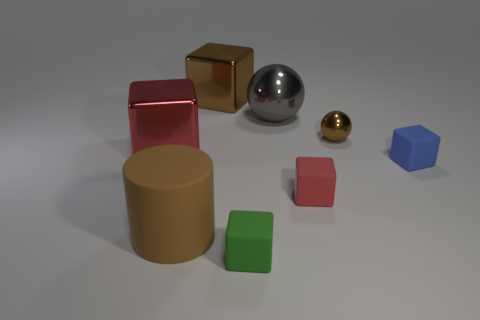Subtract all brown cubes. How many cubes are left? 4 Subtract all brown metal cubes. How many cubes are left? 4 Subtract all cyan blocks. Subtract all purple balls. How many blocks are left? 5 Add 1 tiny green blocks. How many objects exist? 9 Subtract all cubes. How many objects are left? 3 Subtract 1 brown cylinders. How many objects are left? 7 Subtract all small cubes. Subtract all red blocks. How many objects are left? 3 Add 1 big brown cylinders. How many big brown cylinders are left? 2 Add 4 brown rubber objects. How many brown rubber objects exist? 5 